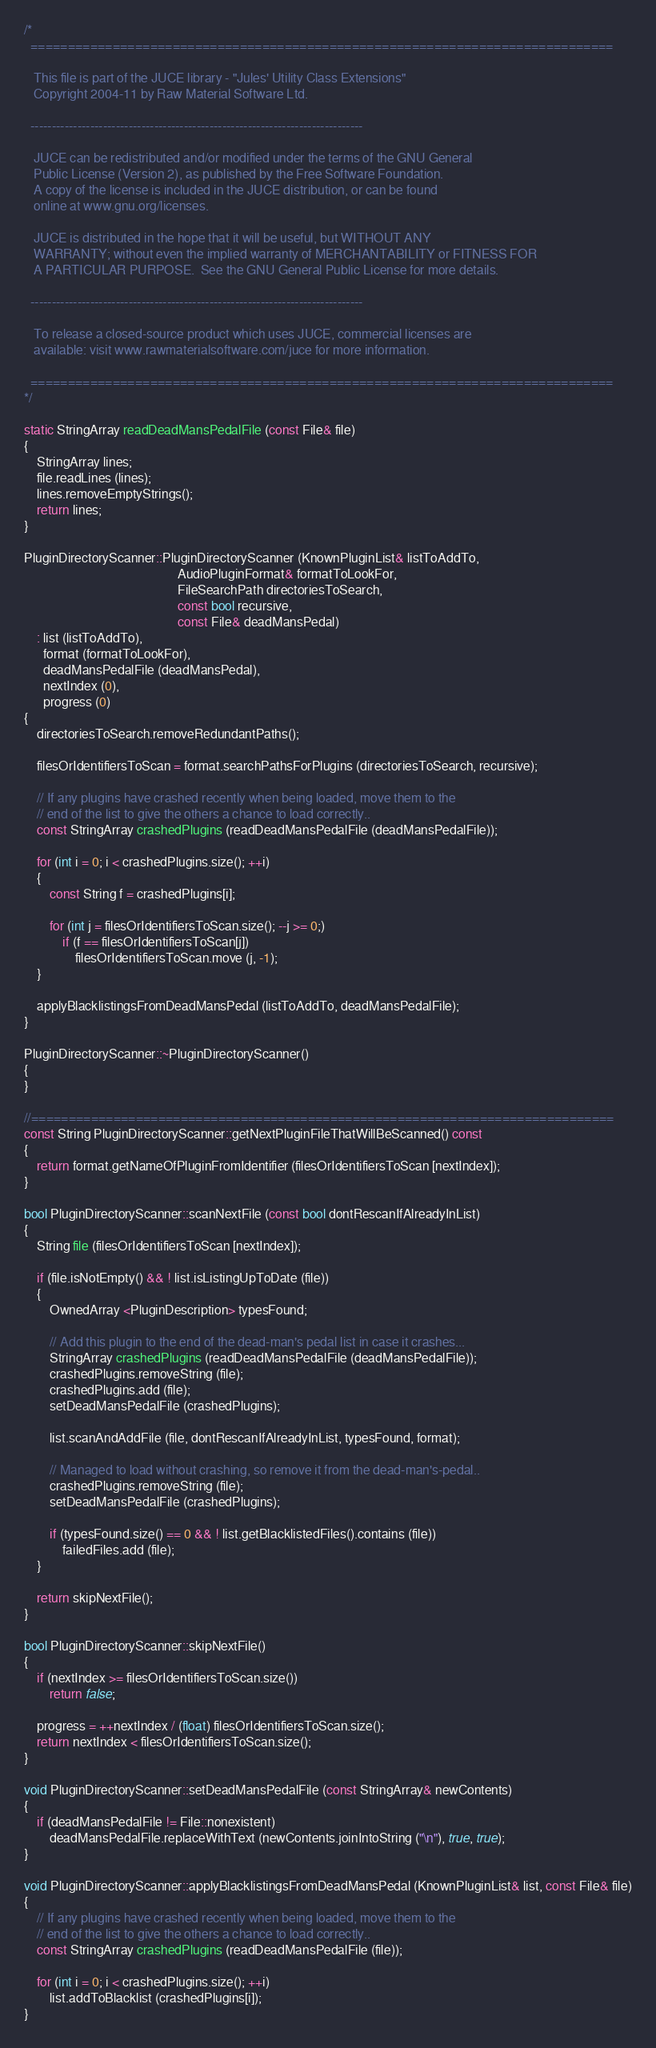<code> <loc_0><loc_0><loc_500><loc_500><_C++_>/*
  ==============================================================================

   This file is part of the JUCE library - "Jules' Utility Class Extensions"
   Copyright 2004-11 by Raw Material Software Ltd.

  ------------------------------------------------------------------------------

   JUCE can be redistributed and/or modified under the terms of the GNU General
   Public License (Version 2), as published by the Free Software Foundation.
   A copy of the license is included in the JUCE distribution, or can be found
   online at www.gnu.org/licenses.

   JUCE is distributed in the hope that it will be useful, but WITHOUT ANY
   WARRANTY; without even the implied warranty of MERCHANTABILITY or FITNESS FOR
   A PARTICULAR PURPOSE.  See the GNU General Public License for more details.

  ------------------------------------------------------------------------------

   To release a closed-source product which uses JUCE, commercial licenses are
   available: visit www.rawmaterialsoftware.com/juce for more information.

  ==============================================================================
*/

static StringArray readDeadMansPedalFile (const File& file)
{
    StringArray lines;
    file.readLines (lines);
    lines.removeEmptyStrings();
    return lines;
}

PluginDirectoryScanner::PluginDirectoryScanner (KnownPluginList& listToAddTo,
                                                AudioPluginFormat& formatToLookFor,
                                                FileSearchPath directoriesToSearch,
                                                const bool recursive,
                                                const File& deadMansPedal)
    : list (listToAddTo),
      format (formatToLookFor),
      deadMansPedalFile (deadMansPedal),
      nextIndex (0),
      progress (0)
{
    directoriesToSearch.removeRedundantPaths();

    filesOrIdentifiersToScan = format.searchPathsForPlugins (directoriesToSearch, recursive);

    // If any plugins have crashed recently when being loaded, move them to the
    // end of the list to give the others a chance to load correctly..
    const StringArray crashedPlugins (readDeadMansPedalFile (deadMansPedalFile));

    for (int i = 0; i < crashedPlugins.size(); ++i)
    {
        const String f = crashedPlugins[i];

        for (int j = filesOrIdentifiersToScan.size(); --j >= 0;)
            if (f == filesOrIdentifiersToScan[j])
                filesOrIdentifiersToScan.move (j, -1);
    }

    applyBlacklistingsFromDeadMansPedal (listToAddTo, deadMansPedalFile);
}

PluginDirectoryScanner::~PluginDirectoryScanner()
{
}

//==============================================================================
const String PluginDirectoryScanner::getNextPluginFileThatWillBeScanned() const
{
    return format.getNameOfPluginFromIdentifier (filesOrIdentifiersToScan [nextIndex]);
}

bool PluginDirectoryScanner::scanNextFile (const bool dontRescanIfAlreadyInList)
{
    String file (filesOrIdentifiersToScan [nextIndex]);

    if (file.isNotEmpty() && ! list.isListingUpToDate (file))
    {
        OwnedArray <PluginDescription> typesFound;

        // Add this plugin to the end of the dead-man's pedal list in case it crashes...
        StringArray crashedPlugins (readDeadMansPedalFile (deadMansPedalFile));
        crashedPlugins.removeString (file);
        crashedPlugins.add (file);
        setDeadMansPedalFile (crashedPlugins);

        list.scanAndAddFile (file, dontRescanIfAlreadyInList, typesFound, format);

        // Managed to load without crashing, so remove it from the dead-man's-pedal..
        crashedPlugins.removeString (file);
        setDeadMansPedalFile (crashedPlugins);

        if (typesFound.size() == 0 && ! list.getBlacklistedFiles().contains (file))
            failedFiles.add (file);
    }

    return skipNextFile();
}

bool PluginDirectoryScanner::skipNextFile()
{
    if (nextIndex >= filesOrIdentifiersToScan.size())
        return false;

    progress = ++nextIndex / (float) filesOrIdentifiersToScan.size();
    return nextIndex < filesOrIdentifiersToScan.size();
}

void PluginDirectoryScanner::setDeadMansPedalFile (const StringArray& newContents)
{
    if (deadMansPedalFile != File::nonexistent)
        deadMansPedalFile.replaceWithText (newContents.joinIntoString ("\n"), true, true);
}

void PluginDirectoryScanner::applyBlacklistingsFromDeadMansPedal (KnownPluginList& list, const File& file)
{
    // If any plugins have crashed recently when being loaded, move them to the
    // end of the list to give the others a chance to load correctly..
    const StringArray crashedPlugins (readDeadMansPedalFile (file));

    for (int i = 0; i < crashedPlugins.size(); ++i)
        list.addToBlacklist (crashedPlugins[i]);
}
</code> 